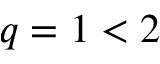<formula> <loc_0><loc_0><loc_500><loc_500>q = 1 < 2</formula> 